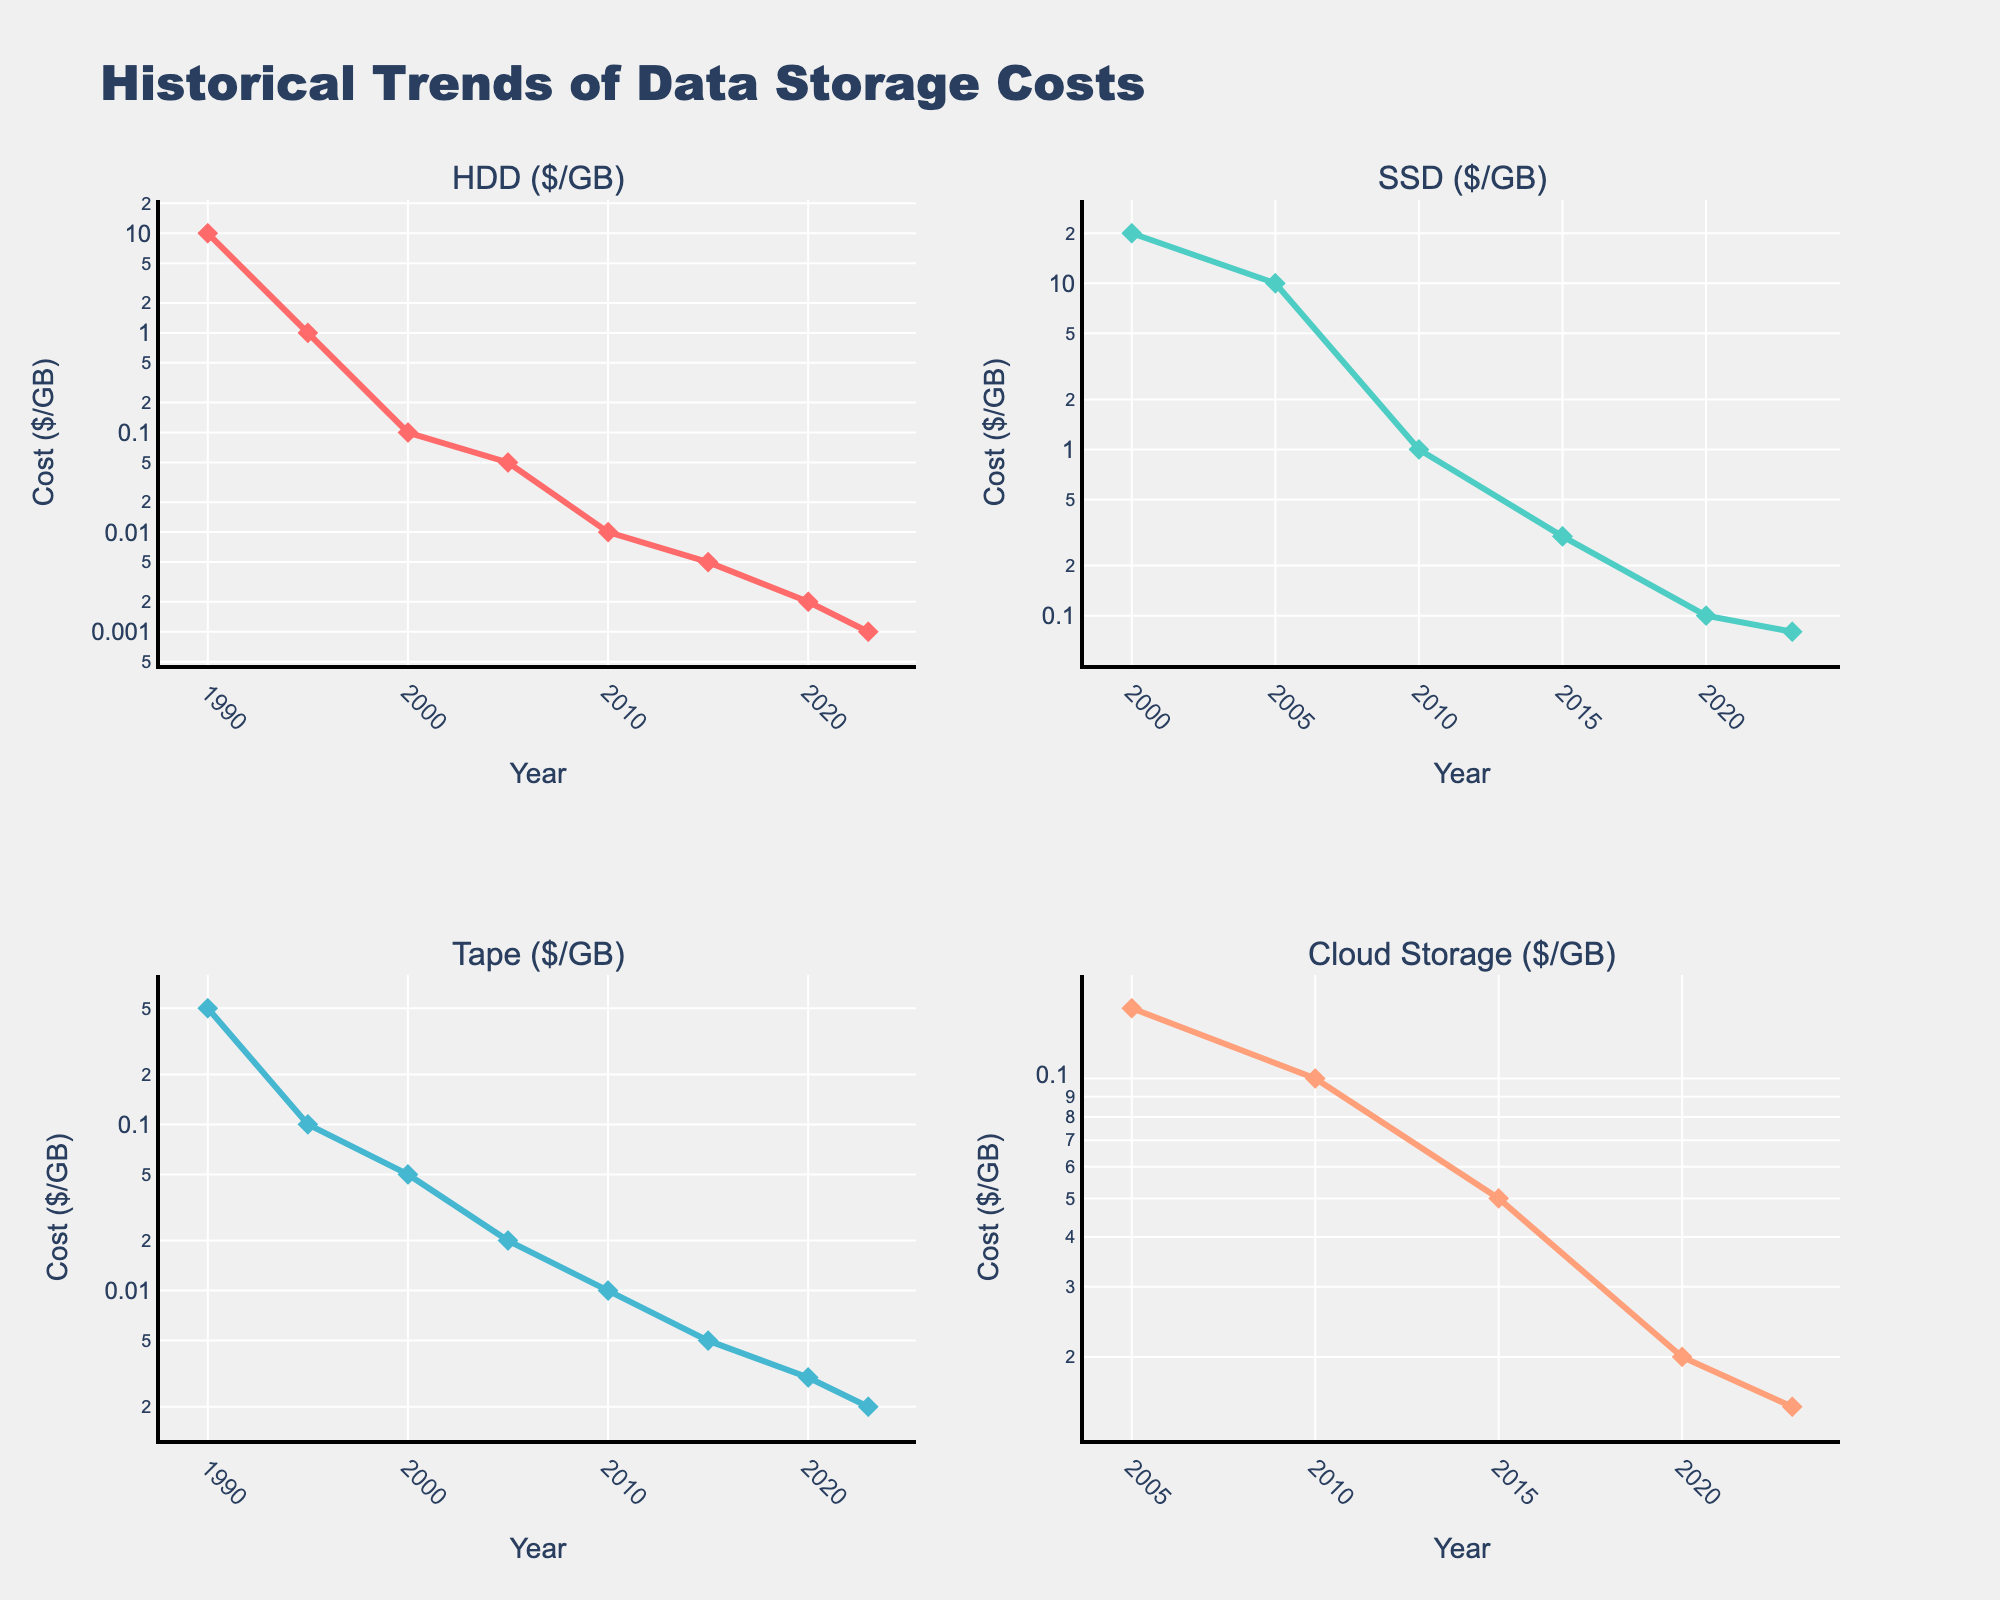What is the title of the figure? The title of the figure is right at the top and denotes the theme of the plots. It reads "Historical Trends of Data Storage Costs".
Answer: Historical Trends of Data Storage Costs What is the y-axis label for each subplot? The y-axis labels for each subplot represent the cost metric being measured and they all read "Cost ($/GB)".
Answer: Cost ($/GB) Which storage type was the most expensive in the year 2010? From the subplots, we can observe that in 2010, SSD had the highest cost as compared to HDD, Tape, and Cloud Storage. The cost for SSD was significantly higher.
Answer: SSD How many storage types have been displayed over the years? By looking at the subplots, we see four distinct storage types: HDD, SSD, Tape, and Cloud Storage.
Answer: Four Between which years did the cost of Cloud Storage show the steepest decline? By observing the Cloud Storage subplot, the sharpest decline in cost is visible from 2010 to 2015 when the prices dropped from approximately $0.10/GB to $0.05/GB.
Answer: 2010 to 2015 Which storage type shows a continuous reduction in cost across all years without any increase? By examining all subplots, HDD shows a continuous reduction in cost from 1990 to 2023 without any increase.
Answer: HDD What is the trend of tape storage costs from 2000 to 2023? The tape storage costs decrease from 2000 ($0.05/GB) to 2023 ($0.002/GB). This implies a continuous downward trend over the years.
Answer: Downward trend Which year did SSD first become less expensive than Cloud Storage? By comparing the SSD subplot with the Cloud Storage subplot, the year SSD first became less expensive than Cloud Storage is 2020, where SSD costs $0.10/GB and Cloud Storage costs $0.02/GB.
Answer: 2020 In which years is data available for Cloud Storage? By referring to the Cloud Storage subplot and the data points marked, the years with available data for Cloud Storage are: 2005, 2010, 2015, 2020, and 2023.
Answer: 2005, 2010, 2015, 2020, 2023 In 2023, compare the costs of all storage types and identify the least expensive one. By examining the subplots for the year 2023, the costs are $0.001/GB for HDD, $0.08/GB for SSD, $0.002/GB for Tape, and $0.015/GB for Cloud Storage. HDD is the least expensive.
Answer: HDD 